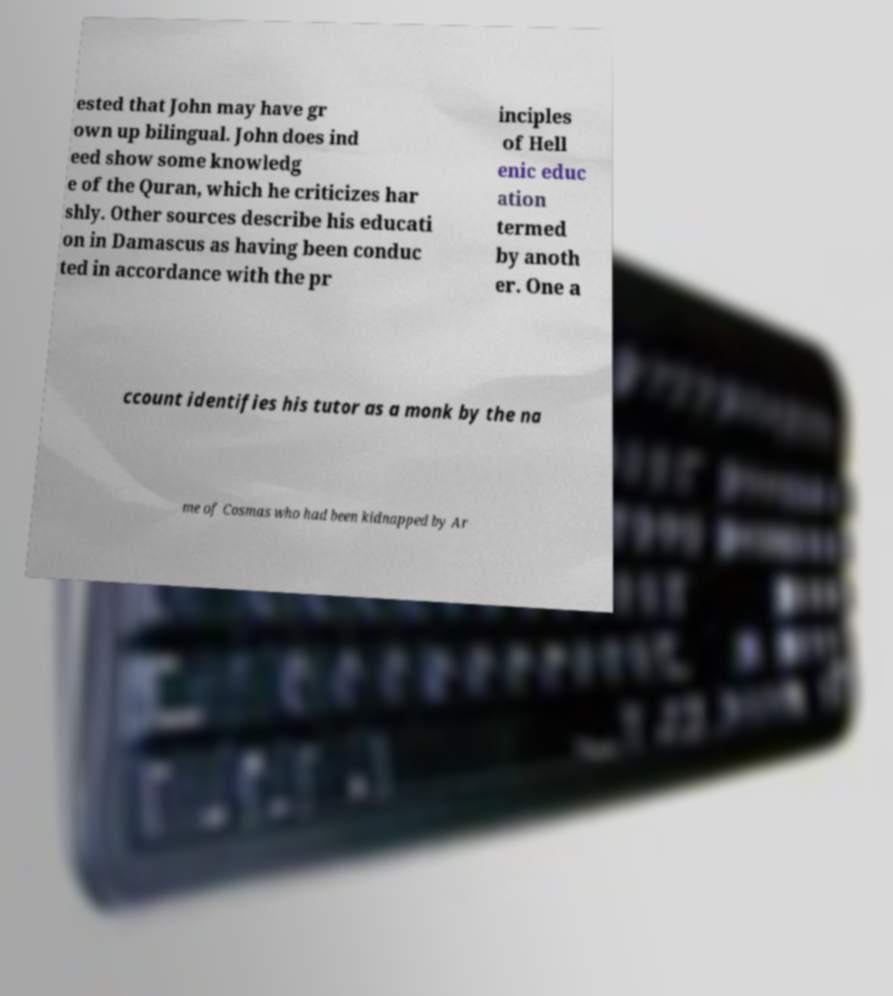What messages or text are displayed in this image? I need them in a readable, typed format. ested that John may have gr own up bilingual. John does ind eed show some knowledg e of the Quran, which he criticizes har shly. Other sources describe his educati on in Damascus as having been conduc ted in accordance with the pr inciples of Hell enic educ ation termed by anoth er. One a ccount identifies his tutor as a monk by the na me of Cosmas who had been kidnapped by Ar 